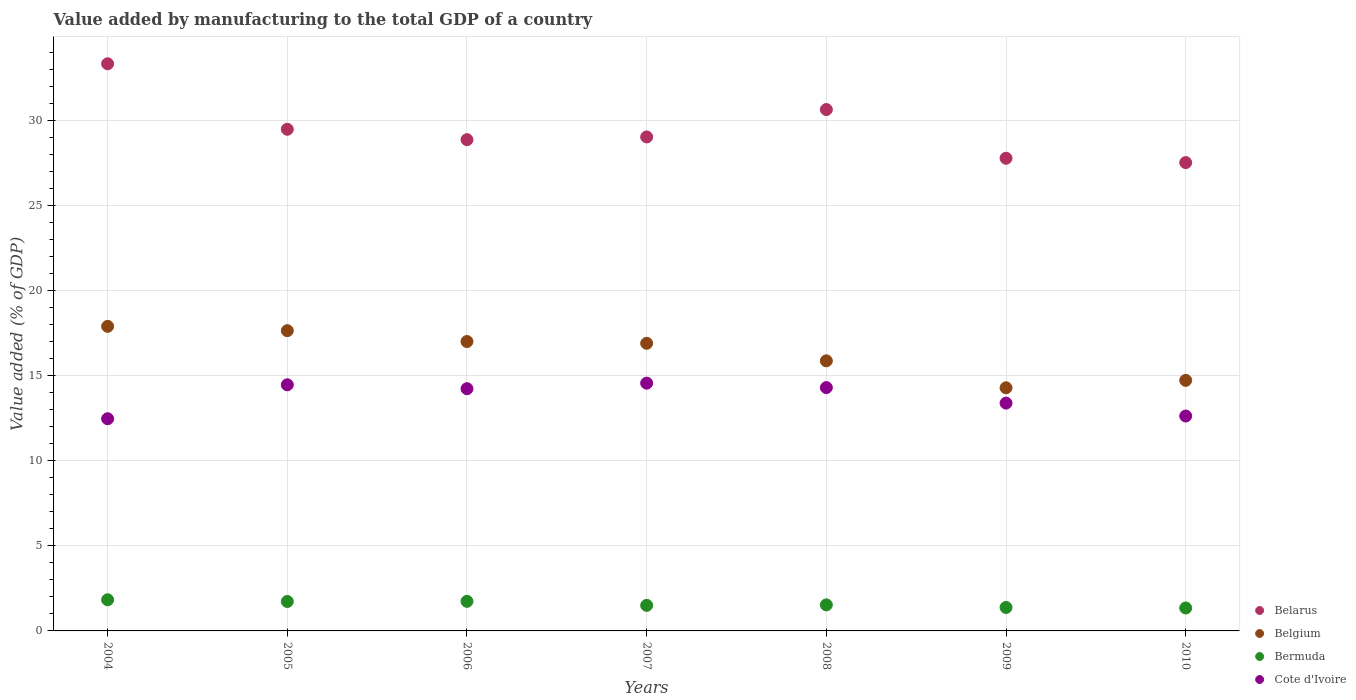What is the value added by manufacturing to the total GDP in Bermuda in 2008?
Ensure brevity in your answer.  1.53. Across all years, what is the maximum value added by manufacturing to the total GDP in Belgium?
Offer a terse response. 17.89. Across all years, what is the minimum value added by manufacturing to the total GDP in Bermuda?
Your answer should be very brief. 1.35. In which year was the value added by manufacturing to the total GDP in Bermuda maximum?
Offer a very short reply. 2004. In which year was the value added by manufacturing to the total GDP in Belarus minimum?
Keep it short and to the point. 2010. What is the total value added by manufacturing to the total GDP in Belgium in the graph?
Your answer should be compact. 114.31. What is the difference between the value added by manufacturing to the total GDP in Cote d'Ivoire in 2005 and that in 2006?
Provide a succinct answer. 0.23. What is the difference between the value added by manufacturing to the total GDP in Bermuda in 2005 and the value added by manufacturing to the total GDP in Cote d'Ivoire in 2009?
Make the answer very short. -11.65. What is the average value added by manufacturing to the total GDP in Cote d'Ivoire per year?
Your answer should be very brief. 13.72. In the year 2006, what is the difference between the value added by manufacturing to the total GDP in Belarus and value added by manufacturing to the total GDP in Belgium?
Offer a very short reply. 11.86. What is the ratio of the value added by manufacturing to the total GDP in Belarus in 2007 to that in 2009?
Offer a very short reply. 1.05. Is the difference between the value added by manufacturing to the total GDP in Belarus in 2004 and 2009 greater than the difference between the value added by manufacturing to the total GDP in Belgium in 2004 and 2009?
Your answer should be compact. Yes. What is the difference between the highest and the second highest value added by manufacturing to the total GDP in Belgium?
Your answer should be compact. 0.25. What is the difference between the highest and the lowest value added by manufacturing to the total GDP in Belgium?
Give a very brief answer. 3.61. In how many years, is the value added by manufacturing to the total GDP in Belarus greater than the average value added by manufacturing to the total GDP in Belarus taken over all years?
Make the answer very short. 2. Is the sum of the value added by manufacturing to the total GDP in Cote d'Ivoire in 2004 and 2006 greater than the maximum value added by manufacturing to the total GDP in Belarus across all years?
Offer a very short reply. No. Is it the case that in every year, the sum of the value added by manufacturing to the total GDP in Cote d'Ivoire and value added by manufacturing to the total GDP in Belgium  is greater than the sum of value added by manufacturing to the total GDP in Bermuda and value added by manufacturing to the total GDP in Belarus?
Provide a short and direct response. No. Is the value added by manufacturing to the total GDP in Cote d'Ivoire strictly greater than the value added by manufacturing to the total GDP in Belarus over the years?
Ensure brevity in your answer.  No. How many dotlines are there?
Make the answer very short. 4. How many years are there in the graph?
Give a very brief answer. 7. What is the difference between two consecutive major ticks on the Y-axis?
Keep it short and to the point. 5. Does the graph contain any zero values?
Provide a short and direct response. No. Does the graph contain grids?
Ensure brevity in your answer.  Yes. Where does the legend appear in the graph?
Offer a very short reply. Bottom right. How many legend labels are there?
Provide a succinct answer. 4. What is the title of the graph?
Your response must be concise. Value added by manufacturing to the total GDP of a country. Does "Panama" appear as one of the legend labels in the graph?
Your answer should be compact. No. What is the label or title of the Y-axis?
Your response must be concise. Value added (% of GDP). What is the Value added (% of GDP) in Belarus in 2004?
Make the answer very short. 33.32. What is the Value added (% of GDP) of Belgium in 2004?
Provide a short and direct response. 17.89. What is the Value added (% of GDP) in Bermuda in 2004?
Your response must be concise. 1.83. What is the Value added (% of GDP) in Cote d'Ivoire in 2004?
Your answer should be very brief. 12.47. What is the Value added (% of GDP) in Belarus in 2005?
Provide a succinct answer. 29.47. What is the Value added (% of GDP) in Belgium in 2005?
Make the answer very short. 17.64. What is the Value added (% of GDP) in Bermuda in 2005?
Offer a very short reply. 1.73. What is the Value added (% of GDP) of Cote d'Ivoire in 2005?
Make the answer very short. 14.46. What is the Value added (% of GDP) of Belarus in 2006?
Give a very brief answer. 28.86. What is the Value added (% of GDP) of Belgium in 2006?
Your response must be concise. 17. What is the Value added (% of GDP) in Bermuda in 2006?
Keep it short and to the point. 1.74. What is the Value added (% of GDP) in Cote d'Ivoire in 2006?
Provide a short and direct response. 14.23. What is the Value added (% of GDP) in Belarus in 2007?
Your answer should be very brief. 29.02. What is the Value added (% of GDP) of Belgium in 2007?
Offer a terse response. 16.9. What is the Value added (% of GDP) of Bermuda in 2007?
Your response must be concise. 1.5. What is the Value added (% of GDP) of Cote d'Ivoire in 2007?
Make the answer very short. 14.56. What is the Value added (% of GDP) in Belarus in 2008?
Your answer should be compact. 30.63. What is the Value added (% of GDP) of Belgium in 2008?
Offer a very short reply. 15.87. What is the Value added (% of GDP) of Bermuda in 2008?
Your answer should be very brief. 1.53. What is the Value added (% of GDP) of Cote d'Ivoire in 2008?
Give a very brief answer. 14.3. What is the Value added (% of GDP) in Belarus in 2009?
Your answer should be very brief. 27.77. What is the Value added (% of GDP) of Belgium in 2009?
Provide a succinct answer. 14.28. What is the Value added (% of GDP) of Bermuda in 2009?
Your response must be concise. 1.38. What is the Value added (% of GDP) of Cote d'Ivoire in 2009?
Keep it short and to the point. 13.38. What is the Value added (% of GDP) of Belarus in 2010?
Keep it short and to the point. 27.51. What is the Value added (% of GDP) in Belgium in 2010?
Provide a succinct answer. 14.72. What is the Value added (% of GDP) in Bermuda in 2010?
Provide a short and direct response. 1.35. What is the Value added (% of GDP) in Cote d'Ivoire in 2010?
Your answer should be compact. 12.63. Across all years, what is the maximum Value added (% of GDP) of Belarus?
Offer a terse response. 33.32. Across all years, what is the maximum Value added (% of GDP) in Belgium?
Your answer should be compact. 17.89. Across all years, what is the maximum Value added (% of GDP) of Bermuda?
Give a very brief answer. 1.83. Across all years, what is the maximum Value added (% of GDP) in Cote d'Ivoire?
Provide a succinct answer. 14.56. Across all years, what is the minimum Value added (% of GDP) in Belarus?
Your answer should be very brief. 27.51. Across all years, what is the minimum Value added (% of GDP) of Belgium?
Keep it short and to the point. 14.28. Across all years, what is the minimum Value added (% of GDP) of Bermuda?
Offer a terse response. 1.35. Across all years, what is the minimum Value added (% of GDP) in Cote d'Ivoire?
Your response must be concise. 12.47. What is the total Value added (% of GDP) of Belarus in the graph?
Your answer should be very brief. 206.59. What is the total Value added (% of GDP) in Belgium in the graph?
Keep it short and to the point. 114.31. What is the total Value added (% of GDP) in Bermuda in the graph?
Your response must be concise. 11.06. What is the total Value added (% of GDP) in Cote d'Ivoire in the graph?
Your answer should be compact. 96.02. What is the difference between the Value added (% of GDP) in Belarus in 2004 and that in 2005?
Give a very brief answer. 3.85. What is the difference between the Value added (% of GDP) in Belgium in 2004 and that in 2005?
Make the answer very short. 0.25. What is the difference between the Value added (% of GDP) in Bermuda in 2004 and that in 2005?
Provide a short and direct response. 0.1. What is the difference between the Value added (% of GDP) of Cote d'Ivoire in 2004 and that in 2005?
Make the answer very short. -2. What is the difference between the Value added (% of GDP) in Belarus in 2004 and that in 2006?
Your response must be concise. 4.46. What is the difference between the Value added (% of GDP) of Belgium in 2004 and that in 2006?
Your answer should be compact. 0.89. What is the difference between the Value added (% of GDP) of Bermuda in 2004 and that in 2006?
Give a very brief answer. 0.09. What is the difference between the Value added (% of GDP) in Cote d'Ivoire in 2004 and that in 2006?
Your response must be concise. -1.77. What is the difference between the Value added (% of GDP) of Belarus in 2004 and that in 2007?
Provide a succinct answer. 4.3. What is the difference between the Value added (% of GDP) of Bermuda in 2004 and that in 2007?
Ensure brevity in your answer.  0.33. What is the difference between the Value added (% of GDP) of Cote d'Ivoire in 2004 and that in 2007?
Offer a very short reply. -2.09. What is the difference between the Value added (% of GDP) of Belarus in 2004 and that in 2008?
Offer a terse response. 2.69. What is the difference between the Value added (% of GDP) in Belgium in 2004 and that in 2008?
Your response must be concise. 2.03. What is the difference between the Value added (% of GDP) of Bermuda in 2004 and that in 2008?
Give a very brief answer. 0.3. What is the difference between the Value added (% of GDP) of Cote d'Ivoire in 2004 and that in 2008?
Your answer should be very brief. -1.83. What is the difference between the Value added (% of GDP) of Belarus in 2004 and that in 2009?
Your answer should be compact. 5.55. What is the difference between the Value added (% of GDP) of Belgium in 2004 and that in 2009?
Make the answer very short. 3.61. What is the difference between the Value added (% of GDP) of Bermuda in 2004 and that in 2009?
Offer a very short reply. 0.45. What is the difference between the Value added (% of GDP) of Cote d'Ivoire in 2004 and that in 2009?
Your response must be concise. -0.92. What is the difference between the Value added (% of GDP) of Belarus in 2004 and that in 2010?
Your answer should be compact. 5.81. What is the difference between the Value added (% of GDP) in Belgium in 2004 and that in 2010?
Provide a short and direct response. 3.17. What is the difference between the Value added (% of GDP) of Bermuda in 2004 and that in 2010?
Keep it short and to the point. 0.48. What is the difference between the Value added (% of GDP) in Cote d'Ivoire in 2004 and that in 2010?
Offer a terse response. -0.16. What is the difference between the Value added (% of GDP) of Belarus in 2005 and that in 2006?
Provide a succinct answer. 0.61. What is the difference between the Value added (% of GDP) in Belgium in 2005 and that in 2006?
Your answer should be compact. 0.64. What is the difference between the Value added (% of GDP) of Bermuda in 2005 and that in 2006?
Offer a very short reply. -0.01. What is the difference between the Value added (% of GDP) of Cote d'Ivoire in 2005 and that in 2006?
Provide a short and direct response. 0.23. What is the difference between the Value added (% of GDP) in Belarus in 2005 and that in 2007?
Make the answer very short. 0.45. What is the difference between the Value added (% of GDP) of Belgium in 2005 and that in 2007?
Give a very brief answer. 0.74. What is the difference between the Value added (% of GDP) in Bermuda in 2005 and that in 2007?
Your answer should be compact. 0.23. What is the difference between the Value added (% of GDP) of Cote d'Ivoire in 2005 and that in 2007?
Keep it short and to the point. -0.1. What is the difference between the Value added (% of GDP) in Belarus in 2005 and that in 2008?
Give a very brief answer. -1.16. What is the difference between the Value added (% of GDP) of Belgium in 2005 and that in 2008?
Keep it short and to the point. 1.77. What is the difference between the Value added (% of GDP) in Bermuda in 2005 and that in 2008?
Offer a very short reply. 0.2. What is the difference between the Value added (% of GDP) of Cote d'Ivoire in 2005 and that in 2008?
Make the answer very short. 0.16. What is the difference between the Value added (% of GDP) of Belarus in 2005 and that in 2009?
Offer a terse response. 1.7. What is the difference between the Value added (% of GDP) of Belgium in 2005 and that in 2009?
Give a very brief answer. 3.36. What is the difference between the Value added (% of GDP) in Bermuda in 2005 and that in 2009?
Your answer should be very brief. 0.35. What is the difference between the Value added (% of GDP) in Cote d'Ivoire in 2005 and that in 2009?
Your response must be concise. 1.08. What is the difference between the Value added (% of GDP) in Belarus in 2005 and that in 2010?
Offer a terse response. 1.96. What is the difference between the Value added (% of GDP) of Belgium in 2005 and that in 2010?
Provide a short and direct response. 2.92. What is the difference between the Value added (% of GDP) in Bermuda in 2005 and that in 2010?
Give a very brief answer. 0.38. What is the difference between the Value added (% of GDP) of Cote d'Ivoire in 2005 and that in 2010?
Give a very brief answer. 1.83. What is the difference between the Value added (% of GDP) in Belarus in 2006 and that in 2007?
Keep it short and to the point. -0.16. What is the difference between the Value added (% of GDP) in Belgium in 2006 and that in 2007?
Provide a succinct answer. 0.1. What is the difference between the Value added (% of GDP) of Bermuda in 2006 and that in 2007?
Your answer should be very brief. 0.24. What is the difference between the Value added (% of GDP) in Cote d'Ivoire in 2006 and that in 2007?
Your answer should be compact. -0.33. What is the difference between the Value added (% of GDP) of Belarus in 2006 and that in 2008?
Your answer should be very brief. -1.77. What is the difference between the Value added (% of GDP) in Belgium in 2006 and that in 2008?
Provide a succinct answer. 1.14. What is the difference between the Value added (% of GDP) of Bermuda in 2006 and that in 2008?
Your answer should be compact. 0.21. What is the difference between the Value added (% of GDP) of Cote d'Ivoire in 2006 and that in 2008?
Your response must be concise. -0.07. What is the difference between the Value added (% of GDP) in Belarus in 2006 and that in 2009?
Provide a succinct answer. 1.09. What is the difference between the Value added (% of GDP) in Belgium in 2006 and that in 2009?
Offer a terse response. 2.72. What is the difference between the Value added (% of GDP) in Bermuda in 2006 and that in 2009?
Provide a short and direct response. 0.36. What is the difference between the Value added (% of GDP) of Cote d'Ivoire in 2006 and that in 2009?
Your answer should be very brief. 0.85. What is the difference between the Value added (% of GDP) in Belarus in 2006 and that in 2010?
Your answer should be compact. 1.35. What is the difference between the Value added (% of GDP) in Belgium in 2006 and that in 2010?
Make the answer very short. 2.28. What is the difference between the Value added (% of GDP) of Bermuda in 2006 and that in 2010?
Make the answer very short. 0.39. What is the difference between the Value added (% of GDP) of Cote d'Ivoire in 2006 and that in 2010?
Your response must be concise. 1.6. What is the difference between the Value added (% of GDP) in Belarus in 2007 and that in 2008?
Provide a short and direct response. -1.61. What is the difference between the Value added (% of GDP) of Belgium in 2007 and that in 2008?
Offer a very short reply. 1.03. What is the difference between the Value added (% of GDP) of Bermuda in 2007 and that in 2008?
Provide a short and direct response. -0.03. What is the difference between the Value added (% of GDP) of Cote d'Ivoire in 2007 and that in 2008?
Offer a terse response. 0.26. What is the difference between the Value added (% of GDP) of Belarus in 2007 and that in 2009?
Give a very brief answer. 1.25. What is the difference between the Value added (% of GDP) in Belgium in 2007 and that in 2009?
Your response must be concise. 2.61. What is the difference between the Value added (% of GDP) of Bermuda in 2007 and that in 2009?
Your answer should be compact. 0.12. What is the difference between the Value added (% of GDP) of Cote d'Ivoire in 2007 and that in 2009?
Make the answer very short. 1.17. What is the difference between the Value added (% of GDP) of Belarus in 2007 and that in 2010?
Offer a terse response. 1.51. What is the difference between the Value added (% of GDP) in Belgium in 2007 and that in 2010?
Provide a short and direct response. 2.18. What is the difference between the Value added (% of GDP) of Bermuda in 2007 and that in 2010?
Ensure brevity in your answer.  0.15. What is the difference between the Value added (% of GDP) of Cote d'Ivoire in 2007 and that in 2010?
Make the answer very short. 1.93. What is the difference between the Value added (% of GDP) of Belarus in 2008 and that in 2009?
Your answer should be very brief. 2.86. What is the difference between the Value added (% of GDP) in Belgium in 2008 and that in 2009?
Make the answer very short. 1.58. What is the difference between the Value added (% of GDP) of Bermuda in 2008 and that in 2009?
Ensure brevity in your answer.  0.15. What is the difference between the Value added (% of GDP) of Cote d'Ivoire in 2008 and that in 2009?
Ensure brevity in your answer.  0.91. What is the difference between the Value added (% of GDP) of Belarus in 2008 and that in 2010?
Make the answer very short. 3.12. What is the difference between the Value added (% of GDP) of Belgium in 2008 and that in 2010?
Ensure brevity in your answer.  1.15. What is the difference between the Value added (% of GDP) of Bermuda in 2008 and that in 2010?
Your response must be concise. 0.18. What is the difference between the Value added (% of GDP) of Cote d'Ivoire in 2008 and that in 2010?
Offer a very short reply. 1.67. What is the difference between the Value added (% of GDP) of Belarus in 2009 and that in 2010?
Keep it short and to the point. 0.26. What is the difference between the Value added (% of GDP) of Belgium in 2009 and that in 2010?
Give a very brief answer. -0.44. What is the difference between the Value added (% of GDP) in Bermuda in 2009 and that in 2010?
Your answer should be compact. 0.03. What is the difference between the Value added (% of GDP) of Cote d'Ivoire in 2009 and that in 2010?
Provide a short and direct response. 0.76. What is the difference between the Value added (% of GDP) of Belarus in 2004 and the Value added (% of GDP) of Belgium in 2005?
Keep it short and to the point. 15.68. What is the difference between the Value added (% of GDP) of Belarus in 2004 and the Value added (% of GDP) of Bermuda in 2005?
Your answer should be very brief. 31.59. What is the difference between the Value added (% of GDP) of Belarus in 2004 and the Value added (% of GDP) of Cote d'Ivoire in 2005?
Keep it short and to the point. 18.86. What is the difference between the Value added (% of GDP) in Belgium in 2004 and the Value added (% of GDP) in Bermuda in 2005?
Your answer should be compact. 16.16. What is the difference between the Value added (% of GDP) of Belgium in 2004 and the Value added (% of GDP) of Cote d'Ivoire in 2005?
Give a very brief answer. 3.43. What is the difference between the Value added (% of GDP) in Bermuda in 2004 and the Value added (% of GDP) in Cote d'Ivoire in 2005?
Provide a short and direct response. -12.63. What is the difference between the Value added (% of GDP) in Belarus in 2004 and the Value added (% of GDP) in Belgium in 2006?
Your answer should be compact. 16.32. What is the difference between the Value added (% of GDP) in Belarus in 2004 and the Value added (% of GDP) in Bermuda in 2006?
Keep it short and to the point. 31.58. What is the difference between the Value added (% of GDP) in Belarus in 2004 and the Value added (% of GDP) in Cote d'Ivoire in 2006?
Make the answer very short. 19.09. What is the difference between the Value added (% of GDP) in Belgium in 2004 and the Value added (% of GDP) in Bermuda in 2006?
Your answer should be compact. 16.16. What is the difference between the Value added (% of GDP) in Belgium in 2004 and the Value added (% of GDP) in Cote d'Ivoire in 2006?
Your answer should be compact. 3.66. What is the difference between the Value added (% of GDP) in Bermuda in 2004 and the Value added (% of GDP) in Cote d'Ivoire in 2006?
Offer a very short reply. -12.4. What is the difference between the Value added (% of GDP) of Belarus in 2004 and the Value added (% of GDP) of Belgium in 2007?
Your answer should be compact. 16.42. What is the difference between the Value added (% of GDP) in Belarus in 2004 and the Value added (% of GDP) in Bermuda in 2007?
Your answer should be compact. 31.82. What is the difference between the Value added (% of GDP) of Belarus in 2004 and the Value added (% of GDP) of Cote d'Ivoire in 2007?
Provide a short and direct response. 18.76. What is the difference between the Value added (% of GDP) in Belgium in 2004 and the Value added (% of GDP) in Bermuda in 2007?
Offer a terse response. 16.39. What is the difference between the Value added (% of GDP) of Belgium in 2004 and the Value added (% of GDP) of Cote d'Ivoire in 2007?
Your response must be concise. 3.34. What is the difference between the Value added (% of GDP) in Bermuda in 2004 and the Value added (% of GDP) in Cote d'Ivoire in 2007?
Your response must be concise. -12.73. What is the difference between the Value added (% of GDP) of Belarus in 2004 and the Value added (% of GDP) of Belgium in 2008?
Provide a short and direct response. 17.45. What is the difference between the Value added (% of GDP) of Belarus in 2004 and the Value added (% of GDP) of Bermuda in 2008?
Offer a terse response. 31.79. What is the difference between the Value added (% of GDP) in Belarus in 2004 and the Value added (% of GDP) in Cote d'Ivoire in 2008?
Your answer should be compact. 19.02. What is the difference between the Value added (% of GDP) in Belgium in 2004 and the Value added (% of GDP) in Bermuda in 2008?
Give a very brief answer. 16.36. What is the difference between the Value added (% of GDP) of Belgium in 2004 and the Value added (% of GDP) of Cote d'Ivoire in 2008?
Provide a short and direct response. 3.6. What is the difference between the Value added (% of GDP) of Bermuda in 2004 and the Value added (% of GDP) of Cote d'Ivoire in 2008?
Keep it short and to the point. -12.47. What is the difference between the Value added (% of GDP) in Belarus in 2004 and the Value added (% of GDP) in Belgium in 2009?
Provide a succinct answer. 19.04. What is the difference between the Value added (% of GDP) of Belarus in 2004 and the Value added (% of GDP) of Bermuda in 2009?
Make the answer very short. 31.94. What is the difference between the Value added (% of GDP) of Belarus in 2004 and the Value added (% of GDP) of Cote d'Ivoire in 2009?
Make the answer very short. 19.94. What is the difference between the Value added (% of GDP) in Belgium in 2004 and the Value added (% of GDP) in Bermuda in 2009?
Provide a succinct answer. 16.52. What is the difference between the Value added (% of GDP) in Belgium in 2004 and the Value added (% of GDP) in Cote d'Ivoire in 2009?
Provide a succinct answer. 4.51. What is the difference between the Value added (% of GDP) of Bermuda in 2004 and the Value added (% of GDP) of Cote d'Ivoire in 2009?
Offer a terse response. -11.55. What is the difference between the Value added (% of GDP) in Belarus in 2004 and the Value added (% of GDP) in Belgium in 2010?
Ensure brevity in your answer.  18.6. What is the difference between the Value added (% of GDP) in Belarus in 2004 and the Value added (% of GDP) in Bermuda in 2010?
Give a very brief answer. 31.97. What is the difference between the Value added (% of GDP) in Belarus in 2004 and the Value added (% of GDP) in Cote d'Ivoire in 2010?
Offer a terse response. 20.69. What is the difference between the Value added (% of GDP) in Belgium in 2004 and the Value added (% of GDP) in Bermuda in 2010?
Make the answer very short. 16.55. What is the difference between the Value added (% of GDP) of Belgium in 2004 and the Value added (% of GDP) of Cote d'Ivoire in 2010?
Offer a terse response. 5.27. What is the difference between the Value added (% of GDP) in Bermuda in 2004 and the Value added (% of GDP) in Cote d'Ivoire in 2010?
Ensure brevity in your answer.  -10.8. What is the difference between the Value added (% of GDP) of Belarus in 2005 and the Value added (% of GDP) of Belgium in 2006?
Make the answer very short. 12.47. What is the difference between the Value added (% of GDP) in Belarus in 2005 and the Value added (% of GDP) in Bermuda in 2006?
Make the answer very short. 27.73. What is the difference between the Value added (% of GDP) of Belarus in 2005 and the Value added (% of GDP) of Cote d'Ivoire in 2006?
Your answer should be very brief. 15.24. What is the difference between the Value added (% of GDP) in Belgium in 2005 and the Value added (% of GDP) in Bermuda in 2006?
Offer a very short reply. 15.9. What is the difference between the Value added (% of GDP) of Belgium in 2005 and the Value added (% of GDP) of Cote d'Ivoire in 2006?
Offer a very short reply. 3.41. What is the difference between the Value added (% of GDP) in Bermuda in 2005 and the Value added (% of GDP) in Cote d'Ivoire in 2006?
Your answer should be compact. -12.5. What is the difference between the Value added (% of GDP) in Belarus in 2005 and the Value added (% of GDP) in Belgium in 2007?
Offer a very short reply. 12.57. What is the difference between the Value added (% of GDP) in Belarus in 2005 and the Value added (% of GDP) in Bermuda in 2007?
Your response must be concise. 27.97. What is the difference between the Value added (% of GDP) of Belarus in 2005 and the Value added (% of GDP) of Cote d'Ivoire in 2007?
Keep it short and to the point. 14.92. What is the difference between the Value added (% of GDP) in Belgium in 2005 and the Value added (% of GDP) in Bermuda in 2007?
Provide a succinct answer. 16.14. What is the difference between the Value added (% of GDP) of Belgium in 2005 and the Value added (% of GDP) of Cote d'Ivoire in 2007?
Your answer should be very brief. 3.08. What is the difference between the Value added (% of GDP) in Bermuda in 2005 and the Value added (% of GDP) in Cote d'Ivoire in 2007?
Ensure brevity in your answer.  -12.83. What is the difference between the Value added (% of GDP) of Belarus in 2005 and the Value added (% of GDP) of Belgium in 2008?
Your response must be concise. 13.61. What is the difference between the Value added (% of GDP) of Belarus in 2005 and the Value added (% of GDP) of Bermuda in 2008?
Offer a very short reply. 27.94. What is the difference between the Value added (% of GDP) in Belarus in 2005 and the Value added (% of GDP) in Cote d'Ivoire in 2008?
Your response must be concise. 15.18. What is the difference between the Value added (% of GDP) in Belgium in 2005 and the Value added (% of GDP) in Bermuda in 2008?
Make the answer very short. 16.11. What is the difference between the Value added (% of GDP) of Belgium in 2005 and the Value added (% of GDP) of Cote d'Ivoire in 2008?
Provide a succinct answer. 3.34. What is the difference between the Value added (% of GDP) of Bermuda in 2005 and the Value added (% of GDP) of Cote d'Ivoire in 2008?
Make the answer very short. -12.57. What is the difference between the Value added (% of GDP) in Belarus in 2005 and the Value added (% of GDP) in Belgium in 2009?
Ensure brevity in your answer.  15.19. What is the difference between the Value added (% of GDP) of Belarus in 2005 and the Value added (% of GDP) of Bermuda in 2009?
Offer a very short reply. 28.09. What is the difference between the Value added (% of GDP) in Belarus in 2005 and the Value added (% of GDP) in Cote d'Ivoire in 2009?
Offer a terse response. 16.09. What is the difference between the Value added (% of GDP) of Belgium in 2005 and the Value added (% of GDP) of Bermuda in 2009?
Give a very brief answer. 16.26. What is the difference between the Value added (% of GDP) of Belgium in 2005 and the Value added (% of GDP) of Cote d'Ivoire in 2009?
Provide a short and direct response. 4.26. What is the difference between the Value added (% of GDP) of Bermuda in 2005 and the Value added (% of GDP) of Cote d'Ivoire in 2009?
Offer a very short reply. -11.65. What is the difference between the Value added (% of GDP) of Belarus in 2005 and the Value added (% of GDP) of Belgium in 2010?
Offer a very short reply. 14.75. What is the difference between the Value added (% of GDP) in Belarus in 2005 and the Value added (% of GDP) in Bermuda in 2010?
Your response must be concise. 28.12. What is the difference between the Value added (% of GDP) of Belarus in 2005 and the Value added (% of GDP) of Cote d'Ivoire in 2010?
Keep it short and to the point. 16.85. What is the difference between the Value added (% of GDP) in Belgium in 2005 and the Value added (% of GDP) in Bermuda in 2010?
Offer a very short reply. 16.29. What is the difference between the Value added (% of GDP) of Belgium in 2005 and the Value added (% of GDP) of Cote d'Ivoire in 2010?
Provide a short and direct response. 5.02. What is the difference between the Value added (% of GDP) in Bermuda in 2005 and the Value added (% of GDP) in Cote d'Ivoire in 2010?
Give a very brief answer. -10.9. What is the difference between the Value added (% of GDP) of Belarus in 2006 and the Value added (% of GDP) of Belgium in 2007?
Offer a very short reply. 11.96. What is the difference between the Value added (% of GDP) in Belarus in 2006 and the Value added (% of GDP) in Bermuda in 2007?
Your answer should be very brief. 27.36. What is the difference between the Value added (% of GDP) in Belarus in 2006 and the Value added (% of GDP) in Cote d'Ivoire in 2007?
Give a very brief answer. 14.3. What is the difference between the Value added (% of GDP) in Belgium in 2006 and the Value added (% of GDP) in Bermuda in 2007?
Offer a very short reply. 15.5. What is the difference between the Value added (% of GDP) of Belgium in 2006 and the Value added (% of GDP) of Cote d'Ivoire in 2007?
Make the answer very short. 2.45. What is the difference between the Value added (% of GDP) of Bermuda in 2006 and the Value added (% of GDP) of Cote d'Ivoire in 2007?
Your answer should be compact. -12.82. What is the difference between the Value added (% of GDP) in Belarus in 2006 and the Value added (% of GDP) in Belgium in 2008?
Make the answer very short. 12.99. What is the difference between the Value added (% of GDP) of Belarus in 2006 and the Value added (% of GDP) of Bermuda in 2008?
Your answer should be very brief. 27.33. What is the difference between the Value added (% of GDP) of Belarus in 2006 and the Value added (% of GDP) of Cote d'Ivoire in 2008?
Make the answer very short. 14.57. What is the difference between the Value added (% of GDP) of Belgium in 2006 and the Value added (% of GDP) of Bermuda in 2008?
Ensure brevity in your answer.  15.47. What is the difference between the Value added (% of GDP) of Belgium in 2006 and the Value added (% of GDP) of Cote d'Ivoire in 2008?
Keep it short and to the point. 2.71. What is the difference between the Value added (% of GDP) of Bermuda in 2006 and the Value added (% of GDP) of Cote d'Ivoire in 2008?
Your answer should be compact. -12.56. What is the difference between the Value added (% of GDP) of Belarus in 2006 and the Value added (% of GDP) of Belgium in 2009?
Your answer should be compact. 14.58. What is the difference between the Value added (% of GDP) in Belarus in 2006 and the Value added (% of GDP) in Bermuda in 2009?
Ensure brevity in your answer.  27.48. What is the difference between the Value added (% of GDP) in Belarus in 2006 and the Value added (% of GDP) in Cote d'Ivoire in 2009?
Offer a terse response. 15.48. What is the difference between the Value added (% of GDP) in Belgium in 2006 and the Value added (% of GDP) in Bermuda in 2009?
Provide a succinct answer. 15.62. What is the difference between the Value added (% of GDP) in Belgium in 2006 and the Value added (% of GDP) in Cote d'Ivoire in 2009?
Keep it short and to the point. 3.62. What is the difference between the Value added (% of GDP) of Bermuda in 2006 and the Value added (% of GDP) of Cote d'Ivoire in 2009?
Give a very brief answer. -11.65. What is the difference between the Value added (% of GDP) of Belarus in 2006 and the Value added (% of GDP) of Belgium in 2010?
Offer a terse response. 14.14. What is the difference between the Value added (% of GDP) in Belarus in 2006 and the Value added (% of GDP) in Bermuda in 2010?
Your response must be concise. 27.51. What is the difference between the Value added (% of GDP) of Belarus in 2006 and the Value added (% of GDP) of Cote d'Ivoire in 2010?
Ensure brevity in your answer.  16.24. What is the difference between the Value added (% of GDP) of Belgium in 2006 and the Value added (% of GDP) of Bermuda in 2010?
Give a very brief answer. 15.65. What is the difference between the Value added (% of GDP) of Belgium in 2006 and the Value added (% of GDP) of Cote d'Ivoire in 2010?
Your answer should be compact. 4.38. What is the difference between the Value added (% of GDP) of Bermuda in 2006 and the Value added (% of GDP) of Cote d'Ivoire in 2010?
Keep it short and to the point. -10.89. What is the difference between the Value added (% of GDP) of Belarus in 2007 and the Value added (% of GDP) of Belgium in 2008?
Ensure brevity in your answer.  13.15. What is the difference between the Value added (% of GDP) in Belarus in 2007 and the Value added (% of GDP) in Bermuda in 2008?
Provide a short and direct response. 27.49. What is the difference between the Value added (% of GDP) in Belarus in 2007 and the Value added (% of GDP) in Cote d'Ivoire in 2008?
Your answer should be very brief. 14.72. What is the difference between the Value added (% of GDP) of Belgium in 2007 and the Value added (% of GDP) of Bermuda in 2008?
Provide a short and direct response. 15.37. What is the difference between the Value added (% of GDP) of Belgium in 2007 and the Value added (% of GDP) of Cote d'Ivoire in 2008?
Your response must be concise. 2.6. What is the difference between the Value added (% of GDP) of Bermuda in 2007 and the Value added (% of GDP) of Cote d'Ivoire in 2008?
Ensure brevity in your answer.  -12.8. What is the difference between the Value added (% of GDP) of Belarus in 2007 and the Value added (% of GDP) of Belgium in 2009?
Provide a succinct answer. 14.74. What is the difference between the Value added (% of GDP) of Belarus in 2007 and the Value added (% of GDP) of Bermuda in 2009?
Keep it short and to the point. 27.64. What is the difference between the Value added (% of GDP) in Belarus in 2007 and the Value added (% of GDP) in Cote d'Ivoire in 2009?
Ensure brevity in your answer.  15.64. What is the difference between the Value added (% of GDP) of Belgium in 2007 and the Value added (% of GDP) of Bermuda in 2009?
Offer a terse response. 15.52. What is the difference between the Value added (% of GDP) of Belgium in 2007 and the Value added (% of GDP) of Cote d'Ivoire in 2009?
Keep it short and to the point. 3.51. What is the difference between the Value added (% of GDP) in Bermuda in 2007 and the Value added (% of GDP) in Cote d'Ivoire in 2009?
Your response must be concise. -11.88. What is the difference between the Value added (% of GDP) of Belarus in 2007 and the Value added (% of GDP) of Belgium in 2010?
Offer a very short reply. 14.3. What is the difference between the Value added (% of GDP) of Belarus in 2007 and the Value added (% of GDP) of Bermuda in 2010?
Keep it short and to the point. 27.67. What is the difference between the Value added (% of GDP) in Belarus in 2007 and the Value added (% of GDP) in Cote d'Ivoire in 2010?
Offer a terse response. 16.4. What is the difference between the Value added (% of GDP) of Belgium in 2007 and the Value added (% of GDP) of Bermuda in 2010?
Provide a succinct answer. 15.55. What is the difference between the Value added (% of GDP) of Belgium in 2007 and the Value added (% of GDP) of Cote d'Ivoire in 2010?
Your answer should be compact. 4.27. What is the difference between the Value added (% of GDP) of Bermuda in 2007 and the Value added (% of GDP) of Cote d'Ivoire in 2010?
Provide a short and direct response. -11.12. What is the difference between the Value added (% of GDP) in Belarus in 2008 and the Value added (% of GDP) in Belgium in 2009?
Provide a short and direct response. 16.35. What is the difference between the Value added (% of GDP) in Belarus in 2008 and the Value added (% of GDP) in Bermuda in 2009?
Offer a very short reply. 29.25. What is the difference between the Value added (% of GDP) in Belarus in 2008 and the Value added (% of GDP) in Cote d'Ivoire in 2009?
Your answer should be very brief. 17.25. What is the difference between the Value added (% of GDP) of Belgium in 2008 and the Value added (% of GDP) of Bermuda in 2009?
Your response must be concise. 14.49. What is the difference between the Value added (% of GDP) of Belgium in 2008 and the Value added (% of GDP) of Cote d'Ivoire in 2009?
Offer a terse response. 2.48. What is the difference between the Value added (% of GDP) in Bermuda in 2008 and the Value added (% of GDP) in Cote d'Ivoire in 2009?
Your answer should be very brief. -11.85. What is the difference between the Value added (% of GDP) in Belarus in 2008 and the Value added (% of GDP) in Belgium in 2010?
Provide a succinct answer. 15.91. What is the difference between the Value added (% of GDP) in Belarus in 2008 and the Value added (% of GDP) in Bermuda in 2010?
Offer a terse response. 29.28. What is the difference between the Value added (% of GDP) in Belarus in 2008 and the Value added (% of GDP) in Cote d'Ivoire in 2010?
Provide a short and direct response. 18.01. What is the difference between the Value added (% of GDP) of Belgium in 2008 and the Value added (% of GDP) of Bermuda in 2010?
Offer a very short reply. 14.52. What is the difference between the Value added (% of GDP) in Belgium in 2008 and the Value added (% of GDP) in Cote d'Ivoire in 2010?
Offer a terse response. 3.24. What is the difference between the Value added (% of GDP) of Bermuda in 2008 and the Value added (% of GDP) of Cote d'Ivoire in 2010?
Your answer should be very brief. -11.1. What is the difference between the Value added (% of GDP) of Belarus in 2009 and the Value added (% of GDP) of Belgium in 2010?
Offer a very short reply. 13.05. What is the difference between the Value added (% of GDP) of Belarus in 2009 and the Value added (% of GDP) of Bermuda in 2010?
Make the answer very short. 26.42. What is the difference between the Value added (% of GDP) of Belarus in 2009 and the Value added (% of GDP) of Cote d'Ivoire in 2010?
Your answer should be compact. 15.14. What is the difference between the Value added (% of GDP) of Belgium in 2009 and the Value added (% of GDP) of Bermuda in 2010?
Provide a succinct answer. 12.94. What is the difference between the Value added (% of GDP) in Belgium in 2009 and the Value added (% of GDP) in Cote d'Ivoire in 2010?
Ensure brevity in your answer.  1.66. What is the difference between the Value added (% of GDP) of Bermuda in 2009 and the Value added (% of GDP) of Cote d'Ivoire in 2010?
Offer a very short reply. -11.25. What is the average Value added (% of GDP) of Belarus per year?
Provide a short and direct response. 29.51. What is the average Value added (% of GDP) in Belgium per year?
Your response must be concise. 16.33. What is the average Value added (% of GDP) in Bermuda per year?
Your response must be concise. 1.58. What is the average Value added (% of GDP) in Cote d'Ivoire per year?
Offer a terse response. 13.72. In the year 2004, what is the difference between the Value added (% of GDP) in Belarus and Value added (% of GDP) in Belgium?
Offer a very short reply. 15.43. In the year 2004, what is the difference between the Value added (% of GDP) of Belarus and Value added (% of GDP) of Bermuda?
Provide a short and direct response. 31.49. In the year 2004, what is the difference between the Value added (% of GDP) of Belarus and Value added (% of GDP) of Cote d'Ivoire?
Provide a succinct answer. 20.85. In the year 2004, what is the difference between the Value added (% of GDP) of Belgium and Value added (% of GDP) of Bermuda?
Provide a succinct answer. 16.06. In the year 2004, what is the difference between the Value added (% of GDP) in Belgium and Value added (% of GDP) in Cote d'Ivoire?
Provide a succinct answer. 5.43. In the year 2004, what is the difference between the Value added (% of GDP) of Bermuda and Value added (% of GDP) of Cote d'Ivoire?
Provide a succinct answer. -10.63. In the year 2005, what is the difference between the Value added (% of GDP) in Belarus and Value added (% of GDP) in Belgium?
Provide a short and direct response. 11.83. In the year 2005, what is the difference between the Value added (% of GDP) of Belarus and Value added (% of GDP) of Bermuda?
Give a very brief answer. 27.74. In the year 2005, what is the difference between the Value added (% of GDP) in Belarus and Value added (% of GDP) in Cote d'Ivoire?
Offer a very short reply. 15.01. In the year 2005, what is the difference between the Value added (% of GDP) of Belgium and Value added (% of GDP) of Bermuda?
Offer a terse response. 15.91. In the year 2005, what is the difference between the Value added (% of GDP) of Belgium and Value added (% of GDP) of Cote d'Ivoire?
Make the answer very short. 3.18. In the year 2005, what is the difference between the Value added (% of GDP) in Bermuda and Value added (% of GDP) in Cote d'Ivoire?
Keep it short and to the point. -12.73. In the year 2006, what is the difference between the Value added (% of GDP) of Belarus and Value added (% of GDP) of Belgium?
Ensure brevity in your answer.  11.86. In the year 2006, what is the difference between the Value added (% of GDP) of Belarus and Value added (% of GDP) of Bermuda?
Offer a very short reply. 27.12. In the year 2006, what is the difference between the Value added (% of GDP) in Belarus and Value added (% of GDP) in Cote d'Ivoire?
Offer a terse response. 14.63. In the year 2006, what is the difference between the Value added (% of GDP) in Belgium and Value added (% of GDP) in Bermuda?
Your answer should be very brief. 15.27. In the year 2006, what is the difference between the Value added (% of GDP) in Belgium and Value added (% of GDP) in Cote d'Ivoire?
Your response must be concise. 2.77. In the year 2006, what is the difference between the Value added (% of GDP) in Bermuda and Value added (% of GDP) in Cote d'Ivoire?
Give a very brief answer. -12.49. In the year 2007, what is the difference between the Value added (% of GDP) of Belarus and Value added (% of GDP) of Belgium?
Offer a very short reply. 12.12. In the year 2007, what is the difference between the Value added (% of GDP) of Belarus and Value added (% of GDP) of Bermuda?
Provide a succinct answer. 27.52. In the year 2007, what is the difference between the Value added (% of GDP) of Belarus and Value added (% of GDP) of Cote d'Ivoire?
Your answer should be compact. 14.46. In the year 2007, what is the difference between the Value added (% of GDP) of Belgium and Value added (% of GDP) of Bermuda?
Provide a succinct answer. 15.4. In the year 2007, what is the difference between the Value added (% of GDP) in Belgium and Value added (% of GDP) in Cote d'Ivoire?
Offer a very short reply. 2.34. In the year 2007, what is the difference between the Value added (% of GDP) of Bermuda and Value added (% of GDP) of Cote d'Ivoire?
Your answer should be very brief. -13.06. In the year 2008, what is the difference between the Value added (% of GDP) in Belarus and Value added (% of GDP) in Belgium?
Provide a succinct answer. 14.76. In the year 2008, what is the difference between the Value added (% of GDP) in Belarus and Value added (% of GDP) in Bermuda?
Give a very brief answer. 29.1. In the year 2008, what is the difference between the Value added (% of GDP) of Belarus and Value added (% of GDP) of Cote d'Ivoire?
Your answer should be compact. 16.33. In the year 2008, what is the difference between the Value added (% of GDP) in Belgium and Value added (% of GDP) in Bermuda?
Offer a terse response. 14.34. In the year 2008, what is the difference between the Value added (% of GDP) of Belgium and Value added (% of GDP) of Cote d'Ivoire?
Give a very brief answer. 1.57. In the year 2008, what is the difference between the Value added (% of GDP) in Bermuda and Value added (% of GDP) in Cote d'Ivoire?
Your answer should be very brief. -12.77. In the year 2009, what is the difference between the Value added (% of GDP) in Belarus and Value added (% of GDP) in Belgium?
Provide a short and direct response. 13.49. In the year 2009, what is the difference between the Value added (% of GDP) in Belarus and Value added (% of GDP) in Bermuda?
Provide a succinct answer. 26.39. In the year 2009, what is the difference between the Value added (% of GDP) of Belarus and Value added (% of GDP) of Cote d'Ivoire?
Your response must be concise. 14.39. In the year 2009, what is the difference between the Value added (% of GDP) of Belgium and Value added (% of GDP) of Bermuda?
Your answer should be very brief. 12.91. In the year 2009, what is the difference between the Value added (% of GDP) in Belgium and Value added (% of GDP) in Cote d'Ivoire?
Offer a very short reply. 0.9. In the year 2009, what is the difference between the Value added (% of GDP) in Bermuda and Value added (% of GDP) in Cote d'Ivoire?
Give a very brief answer. -12.01. In the year 2010, what is the difference between the Value added (% of GDP) in Belarus and Value added (% of GDP) in Belgium?
Your answer should be very brief. 12.79. In the year 2010, what is the difference between the Value added (% of GDP) in Belarus and Value added (% of GDP) in Bermuda?
Offer a very short reply. 26.17. In the year 2010, what is the difference between the Value added (% of GDP) of Belarus and Value added (% of GDP) of Cote d'Ivoire?
Ensure brevity in your answer.  14.89. In the year 2010, what is the difference between the Value added (% of GDP) of Belgium and Value added (% of GDP) of Bermuda?
Your answer should be compact. 13.37. In the year 2010, what is the difference between the Value added (% of GDP) of Belgium and Value added (% of GDP) of Cote d'Ivoire?
Give a very brief answer. 2.1. In the year 2010, what is the difference between the Value added (% of GDP) in Bermuda and Value added (% of GDP) in Cote d'Ivoire?
Keep it short and to the point. -11.28. What is the ratio of the Value added (% of GDP) of Belarus in 2004 to that in 2005?
Your answer should be very brief. 1.13. What is the ratio of the Value added (% of GDP) in Belgium in 2004 to that in 2005?
Make the answer very short. 1.01. What is the ratio of the Value added (% of GDP) in Bermuda in 2004 to that in 2005?
Keep it short and to the point. 1.06. What is the ratio of the Value added (% of GDP) in Cote d'Ivoire in 2004 to that in 2005?
Offer a very short reply. 0.86. What is the ratio of the Value added (% of GDP) of Belarus in 2004 to that in 2006?
Keep it short and to the point. 1.15. What is the ratio of the Value added (% of GDP) of Belgium in 2004 to that in 2006?
Keep it short and to the point. 1.05. What is the ratio of the Value added (% of GDP) of Bermuda in 2004 to that in 2006?
Provide a succinct answer. 1.05. What is the ratio of the Value added (% of GDP) of Cote d'Ivoire in 2004 to that in 2006?
Offer a terse response. 0.88. What is the ratio of the Value added (% of GDP) of Belarus in 2004 to that in 2007?
Your answer should be very brief. 1.15. What is the ratio of the Value added (% of GDP) in Belgium in 2004 to that in 2007?
Your answer should be very brief. 1.06. What is the ratio of the Value added (% of GDP) of Bermuda in 2004 to that in 2007?
Ensure brevity in your answer.  1.22. What is the ratio of the Value added (% of GDP) of Cote d'Ivoire in 2004 to that in 2007?
Offer a very short reply. 0.86. What is the ratio of the Value added (% of GDP) of Belarus in 2004 to that in 2008?
Give a very brief answer. 1.09. What is the ratio of the Value added (% of GDP) of Belgium in 2004 to that in 2008?
Your response must be concise. 1.13. What is the ratio of the Value added (% of GDP) in Bermuda in 2004 to that in 2008?
Provide a succinct answer. 1.2. What is the ratio of the Value added (% of GDP) of Cote d'Ivoire in 2004 to that in 2008?
Make the answer very short. 0.87. What is the ratio of the Value added (% of GDP) of Belarus in 2004 to that in 2009?
Provide a succinct answer. 1.2. What is the ratio of the Value added (% of GDP) of Belgium in 2004 to that in 2009?
Give a very brief answer. 1.25. What is the ratio of the Value added (% of GDP) of Bermuda in 2004 to that in 2009?
Offer a very short reply. 1.33. What is the ratio of the Value added (% of GDP) of Cote d'Ivoire in 2004 to that in 2009?
Provide a short and direct response. 0.93. What is the ratio of the Value added (% of GDP) in Belarus in 2004 to that in 2010?
Ensure brevity in your answer.  1.21. What is the ratio of the Value added (% of GDP) in Belgium in 2004 to that in 2010?
Your response must be concise. 1.22. What is the ratio of the Value added (% of GDP) of Bermuda in 2004 to that in 2010?
Ensure brevity in your answer.  1.36. What is the ratio of the Value added (% of GDP) in Cote d'Ivoire in 2004 to that in 2010?
Your response must be concise. 0.99. What is the ratio of the Value added (% of GDP) in Belarus in 2005 to that in 2006?
Provide a succinct answer. 1.02. What is the ratio of the Value added (% of GDP) in Belgium in 2005 to that in 2006?
Provide a short and direct response. 1.04. What is the ratio of the Value added (% of GDP) in Bermuda in 2005 to that in 2006?
Provide a short and direct response. 1. What is the ratio of the Value added (% of GDP) in Cote d'Ivoire in 2005 to that in 2006?
Keep it short and to the point. 1.02. What is the ratio of the Value added (% of GDP) of Belarus in 2005 to that in 2007?
Give a very brief answer. 1.02. What is the ratio of the Value added (% of GDP) in Belgium in 2005 to that in 2007?
Offer a terse response. 1.04. What is the ratio of the Value added (% of GDP) of Bermuda in 2005 to that in 2007?
Make the answer very short. 1.15. What is the ratio of the Value added (% of GDP) of Cote d'Ivoire in 2005 to that in 2007?
Provide a succinct answer. 0.99. What is the ratio of the Value added (% of GDP) of Belarus in 2005 to that in 2008?
Offer a very short reply. 0.96. What is the ratio of the Value added (% of GDP) in Belgium in 2005 to that in 2008?
Your answer should be very brief. 1.11. What is the ratio of the Value added (% of GDP) in Bermuda in 2005 to that in 2008?
Keep it short and to the point. 1.13. What is the ratio of the Value added (% of GDP) in Cote d'Ivoire in 2005 to that in 2008?
Keep it short and to the point. 1.01. What is the ratio of the Value added (% of GDP) in Belarus in 2005 to that in 2009?
Your answer should be very brief. 1.06. What is the ratio of the Value added (% of GDP) in Belgium in 2005 to that in 2009?
Offer a very short reply. 1.24. What is the ratio of the Value added (% of GDP) in Bermuda in 2005 to that in 2009?
Provide a succinct answer. 1.26. What is the ratio of the Value added (% of GDP) in Cote d'Ivoire in 2005 to that in 2009?
Provide a short and direct response. 1.08. What is the ratio of the Value added (% of GDP) in Belarus in 2005 to that in 2010?
Your response must be concise. 1.07. What is the ratio of the Value added (% of GDP) of Belgium in 2005 to that in 2010?
Offer a very short reply. 1.2. What is the ratio of the Value added (% of GDP) in Bermuda in 2005 to that in 2010?
Keep it short and to the point. 1.28. What is the ratio of the Value added (% of GDP) of Cote d'Ivoire in 2005 to that in 2010?
Your answer should be compact. 1.15. What is the ratio of the Value added (% of GDP) in Belarus in 2006 to that in 2007?
Keep it short and to the point. 0.99. What is the ratio of the Value added (% of GDP) of Bermuda in 2006 to that in 2007?
Keep it short and to the point. 1.16. What is the ratio of the Value added (% of GDP) in Cote d'Ivoire in 2006 to that in 2007?
Provide a succinct answer. 0.98. What is the ratio of the Value added (% of GDP) of Belarus in 2006 to that in 2008?
Your response must be concise. 0.94. What is the ratio of the Value added (% of GDP) in Belgium in 2006 to that in 2008?
Provide a short and direct response. 1.07. What is the ratio of the Value added (% of GDP) of Bermuda in 2006 to that in 2008?
Your answer should be compact. 1.14. What is the ratio of the Value added (% of GDP) in Belarus in 2006 to that in 2009?
Your answer should be compact. 1.04. What is the ratio of the Value added (% of GDP) in Belgium in 2006 to that in 2009?
Offer a terse response. 1.19. What is the ratio of the Value added (% of GDP) in Bermuda in 2006 to that in 2009?
Provide a short and direct response. 1.26. What is the ratio of the Value added (% of GDP) in Cote d'Ivoire in 2006 to that in 2009?
Ensure brevity in your answer.  1.06. What is the ratio of the Value added (% of GDP) in Belarus in 2006 to that in 2010?
Provide a succinct answer. 1.05. What is the ratio of the Value added (% of GDP) of Belgium in 2006 to that in 2010?
Provide a succinct answer. 1.16. What is the ratio of the Value added (% of GDP) of Bermuda in 2006 to that in 2010?
Your answer should be very brief. 1.29. What is the ratio of the Value added (% of GDP) in Cote d'Ivoire in 2006 to that in 2010?
Make the answer very short. 1.13. What is the ratio of the Value added (% of GDP) of Belgium in 2007 to that in 2008?
Offer a very short reply. 1.06. What is the ratio of the Value added (% of GDP) in Bermuda in 2007 to that in 2008?
Give a very brief answer. 0.98. What is the ratio of the Value added (% of GDP) of Cote d'Ivoire in 2007 to that in 2008?
Your answer should be compact. 1.02. What is the ratio of the Value added (% of GDP) in Belarus in 2007 to that in 2009?
Ensure brevity in your answer.  1.05. What is the ratio of the Value added (% of GDP) of Belgium in 2007 to that in 2009?
Your answer should be very brief. 1.18. What is the ratio of the Value added (% of GDP) of Bermuda in 2007 to that in 2009?
Give a very brief answer. 1.09. What is the ratio of the Value added (% of GDP) of Cote d'Ivoire in 2007 to that in 2009?
Provide a succinct answer. 1.09. What is the ratio of the Value added (% of GDP) of Belarus in 2007 to that in 2010?
Provide a succinct answer. 1.05. What is the ratio of the Value added (% of GDP) in Belgium in 2007 to that in 2010?
Offer a terse response. 1.15. What is the ratio of the Value added (% of GDP) of Bermuda in 2007 to that in 2010?
Offer a very short reply. 1.11. What is the ratio of the Value added (% of GDP) in Cote d'Ivoire in 2007 to that in 2010?
Your answer should be very brief. 1.15. What is the ratio of the Value added (% of GDP) of Belarus in 2008 to that in 2009?
Provide a succinct answer. 1.1. What is the ratio of the Value added (% of GDP) in Belgium in 2008 to that in 2009?
Offer a terse response. 1.11. What is the ratio of the Value added (% of GDP) in Bermuda in 2008 to that in 2009?
Make the answer very short. 1.11. What is the ratio of the Value added (% of GDP) in Cote d'Ivoire in 2008 to that in 2009?
Keep it short and to the point. 1.07. What is the ratio of the Value added (% of GDP) of Belarus in 2008 to that in 2010?
Your response must be concise. 1.11. What is the ratio of the Value added (% of GDP) of Belgium in 2008 to that in 2010?
Provide a short and direct response. 1.08. What is the ratio of the Value added (% of GDP) in Bermuda in 2008 to that in 2010?
Provide a succinct answer. 1.14. What is the ratio of the Value added (% of GDP) in Cote d'Ivoire in 2008 to that in 2010?
Keep it short and to the point. 1.13. What is the ratio of the Value added (% of GDP) in Belarus in 2009 to that in 2010?
Your answer should be compact. 1.01. What is the ratio of the Value added (% of GDP) in Belgium in 2009 to that in 2010?
Provide a succinct answer. 0.97. What is the ratio of the Value added (% of GDP) of Bermuda in 2009 to that in 2010?
Offer a terse response. 1.02. What is the ratio of the Value added (% of GDP) of Cote d'Ivoire in 2009 to that in 2010?
Your response must be concise. 1.06. What is the difference between the highest and the second highest Value added (% of GDP) of Belarus?
Your answer should be very brief. 2.69. What is the difference between the highest and the second highest Value added (% of GDP) of Belgium?
Provide a succinct answer. 0.25. What is the difference between the highest and the second highest Value added (% of GDP) of Bermuda?
Provide a short and direct response. 0.09. What is the difference between the highest and the second highest Value added (% of GDP) of Cote d'Ivoire?
Your response must be concise. 0.1. What is the difference between the highest and the lowest Value added (% of GDP) of Belarus?
Give a very brief answer. 5.81. What is the difference between the highest and the lowest Value added (% of GDP) in Belgium?
Your response must be concise. 3.61. What is the difference between the highest and the lowest Value added (% of GDP) in Bermuda?
Your response must be concise. 0.48. What is the difference between the highest and the lowest Value added (% of GDP) in Cote d'Ivoire?
Make the answer very short. 2.09. 